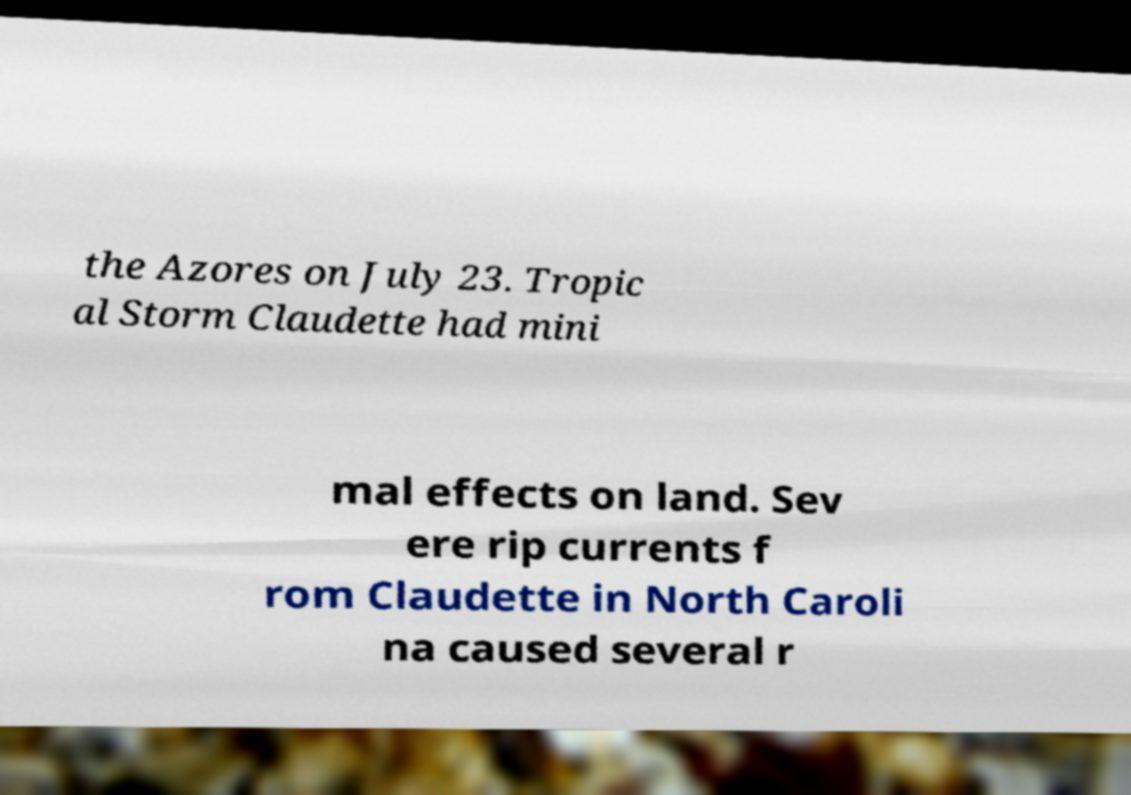There's text embedded in this image that I need extracted. Can you transcribe it verbatim? the Azores on July 23. Tropic al Storm Claudette had mini mal effects on land. Sev ere rip currents f rom Claudette in North Caroli na caused several r 